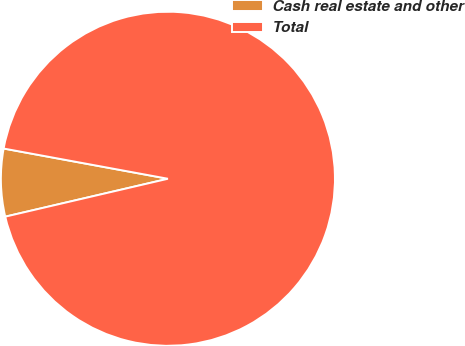<chart> <loc_0><loc_0><loc_500><loc_500><pie_chart><fcel>Cash real estate and other<fcel>Total<nl><fcel>6.54%<fcel>93.46%<nl></chart> 